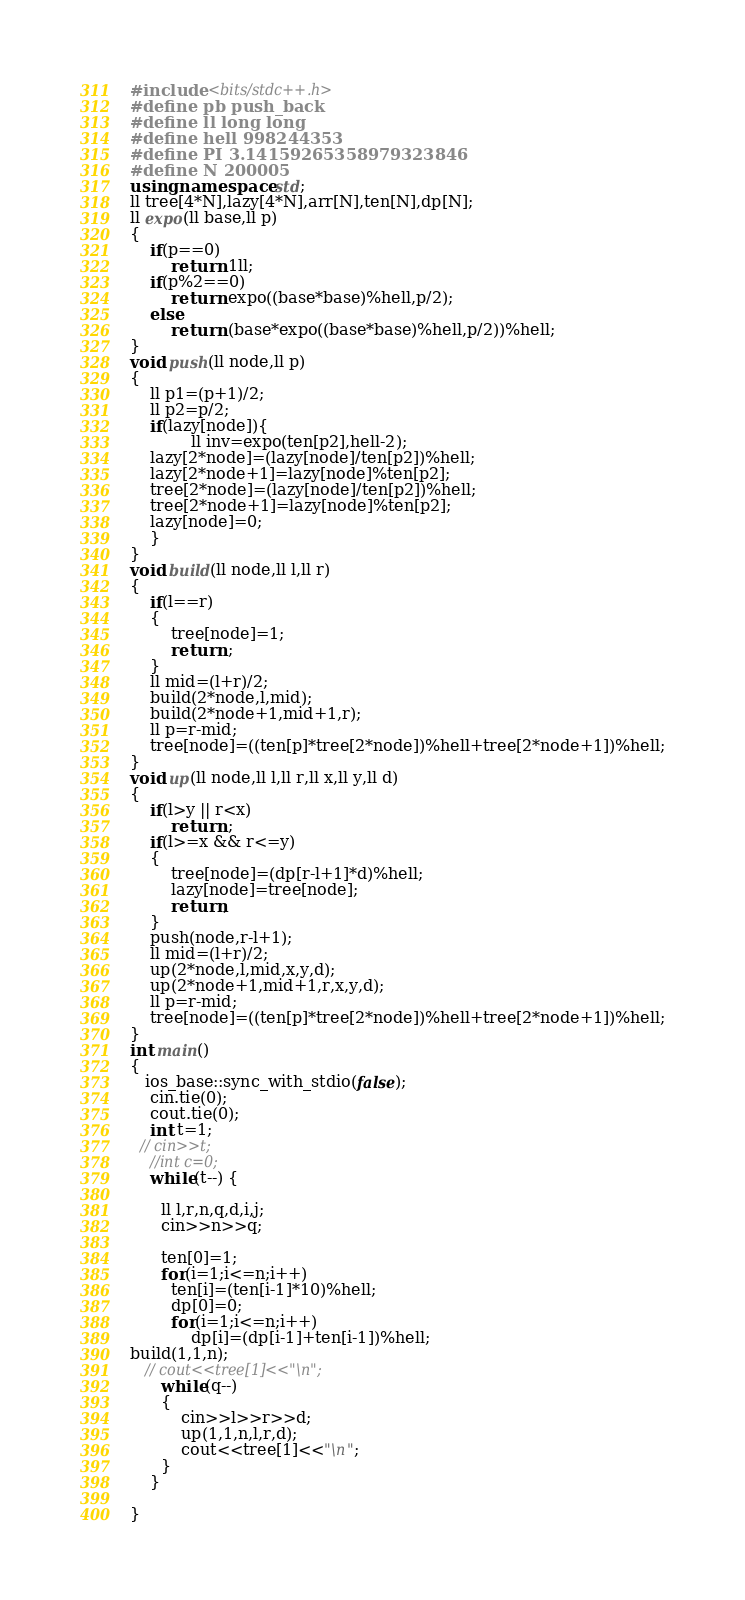<code> <loc_0><loc_0><loc_500><loc_500><_C++_>#include <bits/stdc++.h>
#define pb push_back
#define ll long long
#define hell 998244353
#define PI 3.14159265358979323846
#define N 200005
using namespace std;
ll tree[4*N],lazy[4*N],arr[N],ten[N],dp[N];
ll expo(ll base,ll p)
{
    if(p==0)
        return 1ll;
    if(p%2==0)
        return expo((base*base)%hell,p/2);
    else
        return (base*expo((base*base)%hell,p/2))%hell;
}
void push(ll node,ll p)
{
    ll p1=(p+1)/2;
    ll p2=p/2;
    if(lazy[node]){
            ll inv=expo(ten[p2],hell-2);
    lazy[2*node]=(lazy[node]/ten[p2])%hell;
    lazy[2*node+1]=lazy[node]%ten[p2];
    tree[2*node]=(lazy[node]/ten[p2])%hell;
    tree[2*node+1]=lazy[node]%ten[p2];
    lazy[node]=0;
    }
}
void build(ll node,ll l,ll r)
{
    if(l==r)
    {
        tree[node]=1;
        return ;
    }
    ll mid=(l+r)/2;
    build(2*node,l,mid);
    build(2*node+1,mid+1,r);
    ll p=r-mid;
    tree[node]=((ten[p]*tree[2*node])%hell+tree[2*node+1])%hell;
}
void up(ll node,ll l,ll r,ll x,ll y,ll d)
{
    if(l>y || r<x)
        return ;
    if(l>=x && r<=y)
    {
        tree[node]=(dp[r-l+1]*d)%hell;
        lazy[node]=tree[node];
        return;
    }
    push(node,r-l+1);
    ll mid=(l+r)/2;
    up(2*node,l,mid,x,y,d);
    up(2*node+1,mid+1,r,x,y,d);
    ll p=r-mid;
    tree[node]=((ten[p]*tree[2*node])%hell+tree[2*node+1])%hell;
}
int main()
{
   ios_base::sync_with_stdio(false);
    cin.tie(0);
    cout.tie(0);
    int t=1;
  // cin>>t;
    //int c=0;
    while(t--) {

      ll l,r,n,q,d,i,j;
      cin>>n>>q;

      ten[0]=1;
      for(i=1;i<=n;i++)
        ten[i]=(ten[i-1]*10)%hell;
        dp[0]=0;
        for(i=1;i<=n;i++)
            dp[i]=(dp[i-1]+ten[i-1])%hell;
build(1,1,n);
   // cout<<tree[1]<<"\n";
      while(q--)
      {
          cin>>l>>r>>d;
          up(1,1,n,l,r,d);
          cout<<tree[1]<<"\n";
      }
    }

}
</code> 